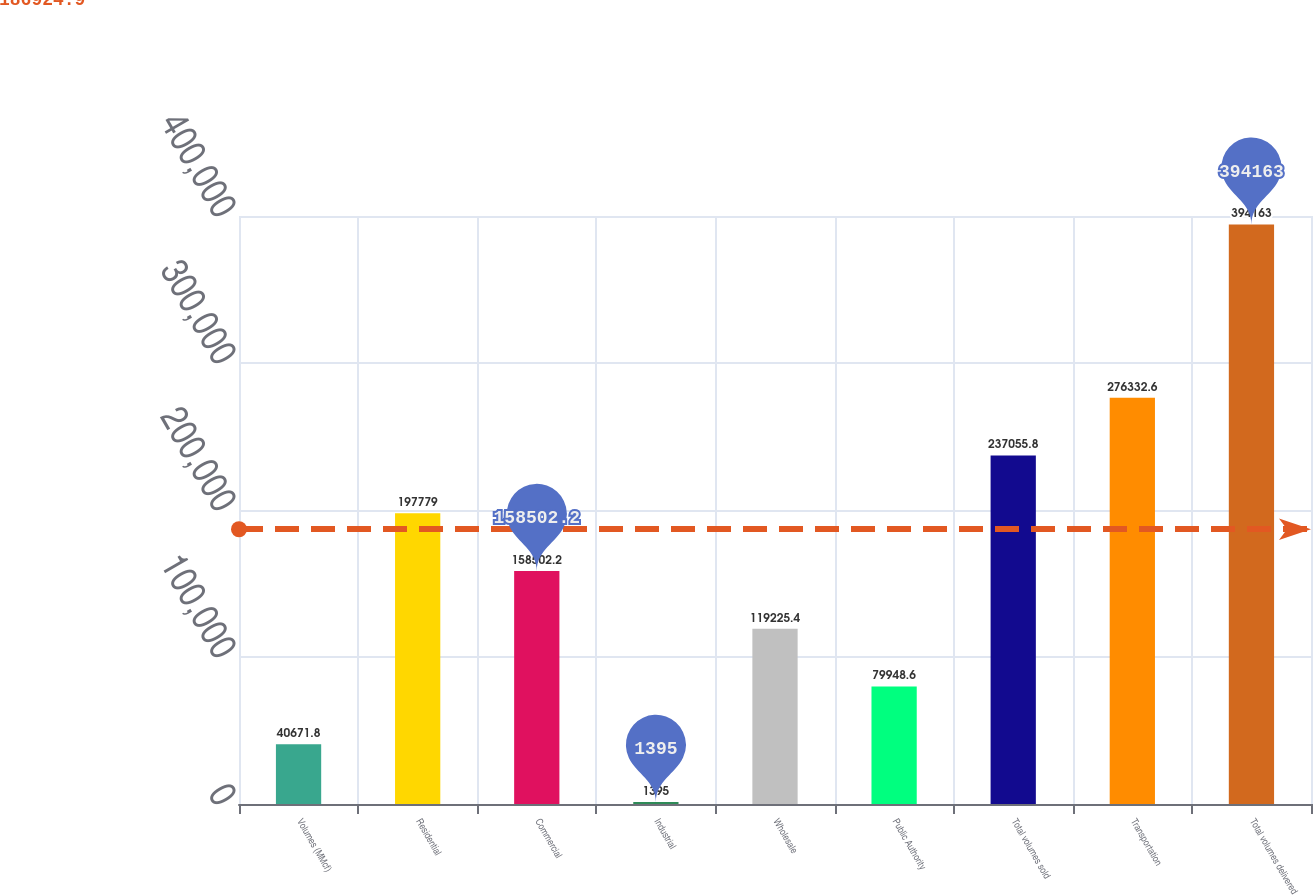Convert chart to OTSL. <chart><loc_0><loc_0><loc_500><loc_500><bar_chart><fcel>Volumes (MMcf)<fcel>Residential<fcel>Commercial<fcel>Industrial<fcel>Wholesale<fcel>Public Authority<fcel>Total volumes sold<fcel>Transportation<fcel>Total volumes delivered<nl><fcel>40671.8<fcel>197779<fcel>158502<fcel>1395<fcel>119225<fcel>79948.6<fcel>237056<fcel>276333<fcel>394163<nl></chart> 